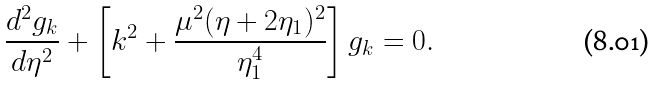<formula> <loc_0><loc_0><loc_500><loc_500>\frac { d ^ { 2 } g _ { k } } { d \eta ^ { 2 } } + \left [ k ^ { 2 } + \frac { \mu ^ { 2 } ( \eta + 2 \eta _ { 1 } ) ^ { 2 } } { \eta _ { 1 } ^ { 4 } } \right ] g _ { k } = 0 .</formula> 